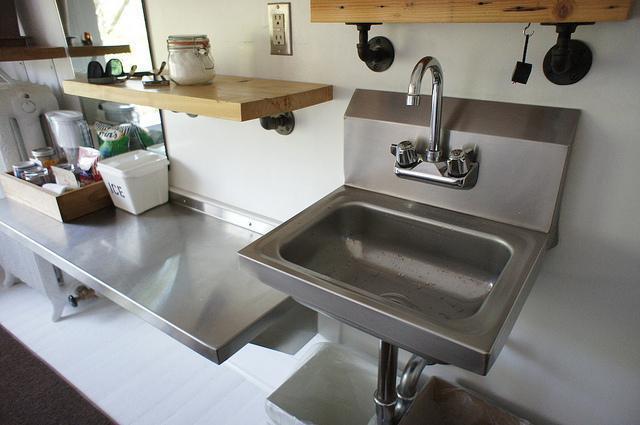How many people are on the benches?
Give a very brief answer. 0. 